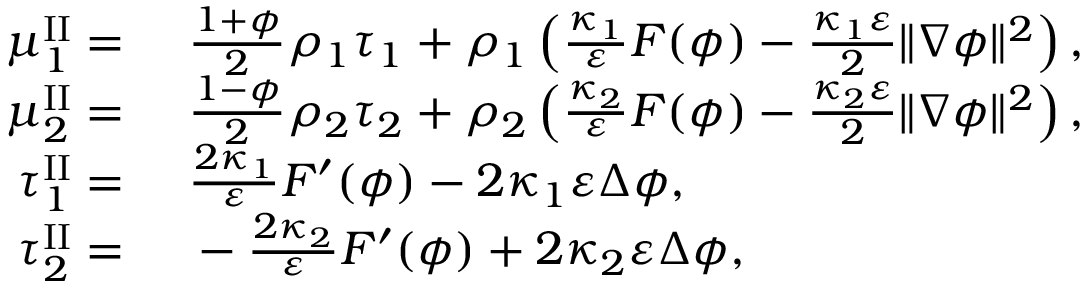<formula> <loc_0><loc_0><loc_500><loc_500>\begin{array} { r l } { \mu _ { 1 } ^ { I I } = } & \frac { 1 + \phi } { 2 } \rho _ { 1 } \tau _ { 1 } + \rho _ { 1 } \left ( \frac { \kappa _ { 1 } } { \varepsilon } F ( \phi ) - \frac { \kappa _ { 1 } \varepsilon } { 2 } \| \nabla \phi \| ^ { 2 } \right ) , } \\ { \mu _ { 2 } ^ { I I } = } & \frac { 1 - \phi } { 2 } \rho _ { 2 } \tau _ { 2 } + \rho _ { 2 } \left ( \frac { \kappa _ { 2 } } { \varepsilon } F ( \phi ) - \frac { \kappa _ { 2 } \varepsilon } { 2 } \| \nabla \phi \| ^ { 2 } \right ) , } \\ { \tau _ { 1 } ^ { I I } = } & \frac { 2 \kappa _ { 1 } } { \varepsilon } F ^ { \prime } ( \phi ) - 2 \kappa _ { 1 } \varepsilon \Delta \phi , } \\ { \tau _ { 2 } ^ { I I } = } & - \frac { 2 \kappa _ { 2 } } { \varepsilon } F ^ { \prime } ( \phi ) + 2 \kappa _ { 2 } \varepsilon \Delta \phi , } \end{array}</formula> 